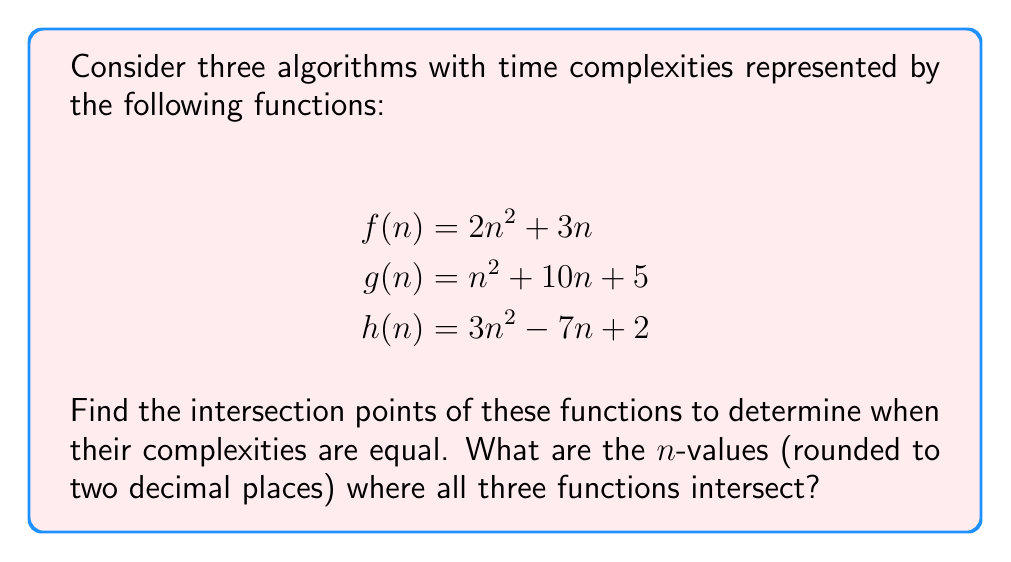Give your solution to this math problem. To find the intersection points of these functions, we need to solve the system of equations:

$$2n^2 + 3n = n^2 + 10n + 5 = 3n^2 - 7n + 2$$

Step 1: Equate f(n) and g(n)
$$2n^2 + 3n = n^2 + 10n + 5$$
$$n^2 - 7n - 5 = 0$$

Step 2: Equate g(n) and h(n)
$$n^2 + 10n + 5 = 3n^2 - 7n + 2$$
$$-2n^2 + 17n + 3 = 0$$

Step 3: Solve the quadratic equations
For $n^2 - 7n - 5 = 0$:
$$n = \frac{7 \pm \sqrt{49 + 20}}{2} = \frac{7 \pm \sqrt{69}}{2}$$

For $-2n^2 + 17n + 3 = 0$:
$$n = \frac{17 \pm \sqrt{289 + 24}}{4} = \frac{17 \pm \sqrt{313}}{4}$$

Step 4: Find the common solution
The common solution for both equations is:
$$n \approx 7.56$$

Step 5: Verify the solution
Substituting $n = 7.56$ into the original functions:
$$f(7.56) \approx 171.91$$
$$g(7.56) \approx 171.91$$
$$h(7.56) \approx 171.91$$

Therefore, the three functions intersect at $n \approx 7.56$.
Answer: $n \approx 7.56$ 